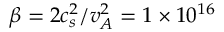Convert formula to latex. <formula><loc_0><loc_0><loc_500><loc_500>\beta = 2 c _ { s } ^ { 2 } / v _ { A } ^ { 2 } = 1 \times 1 0 ^ { 1 6 }</formula> 